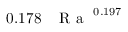Convert formula to latex. <formula><loc_0><loc_0><loc_500><loc_500>0 . 1 7 8 \, { R a } ^ { 0 . 1 9 7 }</formula> 